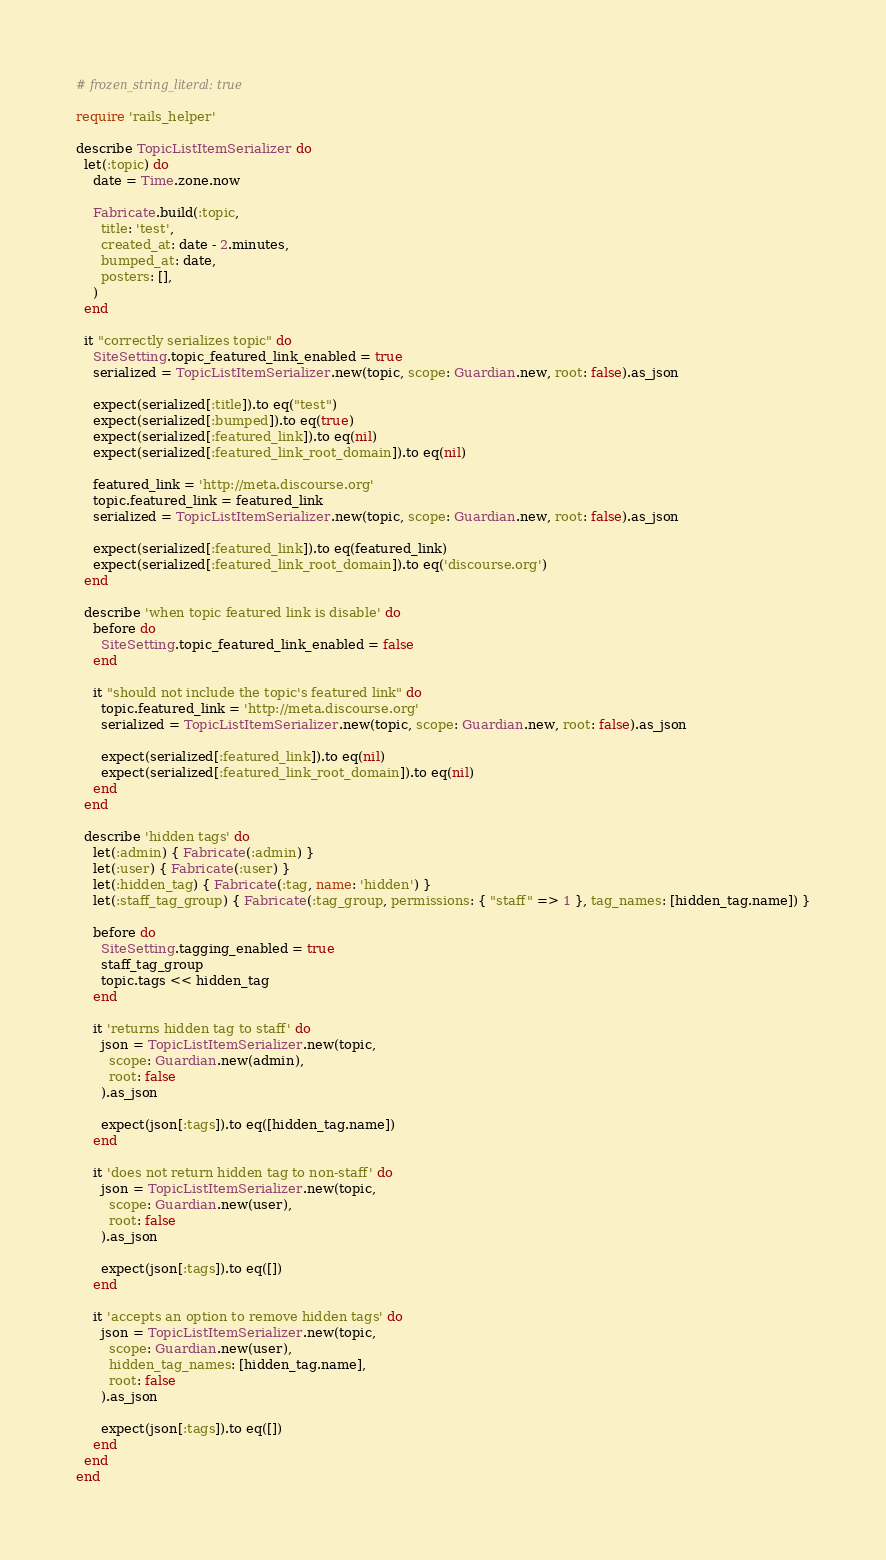Convert code to text. <code><loc_0><loc_0><loc_500><loc_500><_Ruby_># frozen_string_literal: true

require 'rails_helper'

describe TopicListItemSerializer do
  let(:topic) do
    date = Time.zone.now

    Fabricate.build(:topic,
      title: 'test',
      created_at: date - 2.minutes,
      bumped_at: date,
      posters: [],
    )
  end

  it "correctly serializes topic" do
    SiteSetting.topic_featured_link_enabled = true
    serialized = TopicListItemSerializer.new(topic, scope: Guardian.new, root: false).as_json

    expect(serialized[:title]).to eq("test")
    expect(serialized[:bumped]).to eq(true)
    expect(serialized[:featured_link]).to eq(nil)
    expect(serialized[:featured_link_root_domain]).to eq(nil)

    featured_link = 'http://meta.discourse.org'
    topic.featured_link = featured_link
    serialized = TopicListItemSerializer.new(topic, scope: Guardian.new, root: false).as_json

    expect(serialized[:featured_link]).to eq(featured_link)
    expect(serialized[:featured_link_root_domain]).to eq('discourse.org')
  end

  describe 'when topic featured link is disable' do
    before do
      SiteSetting.topic_featured_link_enabled = false
    end

    it "should not include the topic's featured link" do
      topic.featured_link = 'http://meta.discourse.org'
      serialized = TopicListItemSerializer.new(topic, scope: Guardian.new, root: false).as_json

      expect(serialized[:featured_link]).to eq(nil)
      expect(serialized[:featured_link_root_domain]).to eq(nil)
    end
  end

  describe 'hidden tags' do
    let(:admin) { Fabricate(:admin) }
    let(:user) { Fabricate(:user) }
    let(:hidden_tag) { Fabricate(:tag, name: 'hidden') }
    let(:staff_tag_group) { Fabricate(:tag_group, permissions: { "staff" => 1 }, tag_names: [hidden_tag.name]) }

    before do
      SiteSetting.tagging_enabled = true
      staff_tag_group
      topic.tags << hidden_tag
    end

    it 'returns hidden tag to staff' do
      json = TopicListItemSerializer.new(topic,
        scope: Guardian.new(admin),
        root: false
      ).as_json

      expect(json[:tags]).to eq([hidden_tag.name])
    end

    it 'does not return hidden tag to non-staff' do
      json = TopicListItemSerializer.new(topic,
        scope: Guardian.new(user),
        root: false
      ).as_json

      expect(json[:tags]).to eq([])
    end

    it 'accepts an option to remove hidden tags' do
      json = TopicListItemSerializer.new(topic,
        scope: Guardian.new(user),
        hidden_tag_names: [hidden_tag.name],
        root: false
      ).as_json

      expect(json[:tags]).to eq([])
    end
  end
end
</code> 